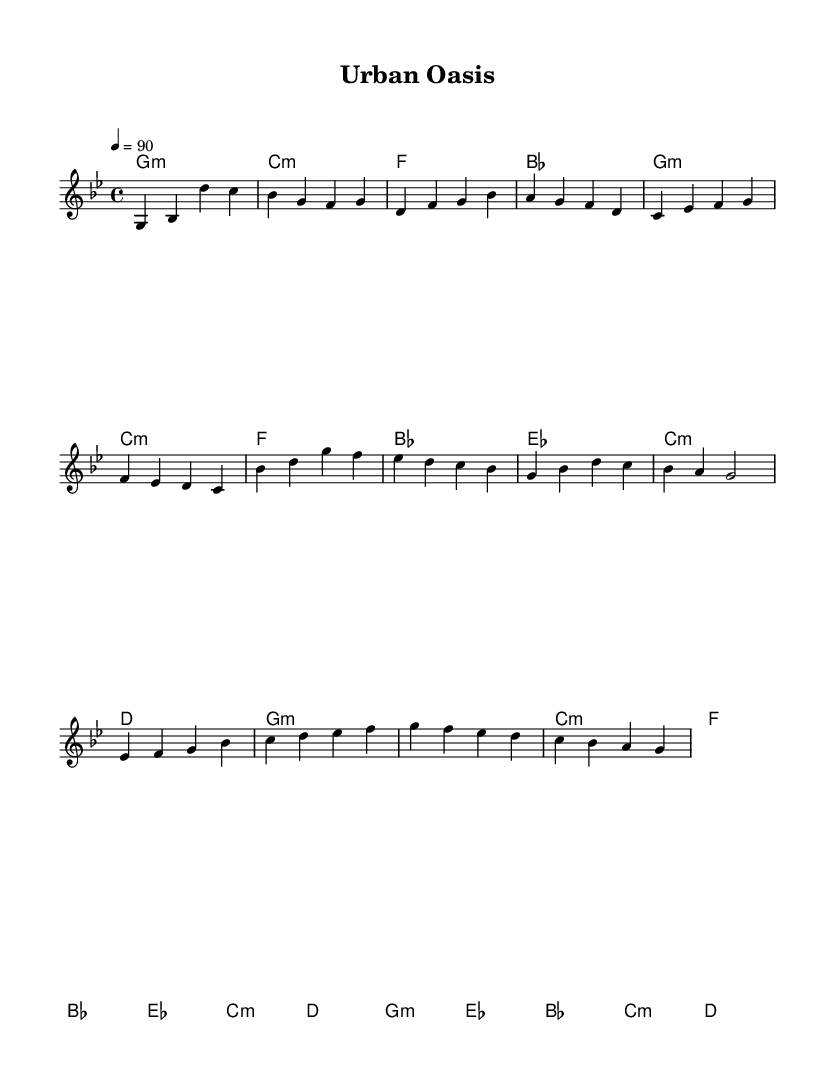What is the key signature of this music? The key signature is G minor, which has two flats (B flat and E flat). This is indicated by the presence of the flat symbols at the beginning of the staff.
Answer: G minor What is the time signature of this piece? The time signature is 4/4, denoted at the beginning of the score by the fraction. This means there are four beats in each measure, with the quarter note receiving one beat.
Answer: 4/4 What is the tempo indicated for the piece? The tempo is set at 90 beats per minute, which is indicated at the beginning of the score with the marking "4 = 90". This tells the performer the speed at which to play the piece.
Answer: 90 How many measures are in the melody? By counting the measures in the melody part of the score, there are a total of 12 measures visible. Each bar line denotes the end of a measure, which aids in carrying out this count.
Answer: 12 Which chord appears in the chorus section? The chord that appears in the chorus is G minor, which is the first chord listed in the sequence of harmony for the chorus. It aligns with the melody that accompanies it.
Answer: G minor How many distinct sections are in the song structure? There are four distinct sections indicated: Intro, Verse, Chorus, and Bridge. Each section is clearly labeled at the beginning of the corresponding musical passages, allowing for easy identification.
Answer: Four What type of music does this sheet represent? This sheet represents Hip Hop due to its lyrical structure and themes of community gardens and green spaces, as indicated in the title and reflective of the artistic style.
Answer: Hip Hop 